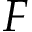<formula> <loc_0><loc_0><loc_500><loc_500>F</formula> 